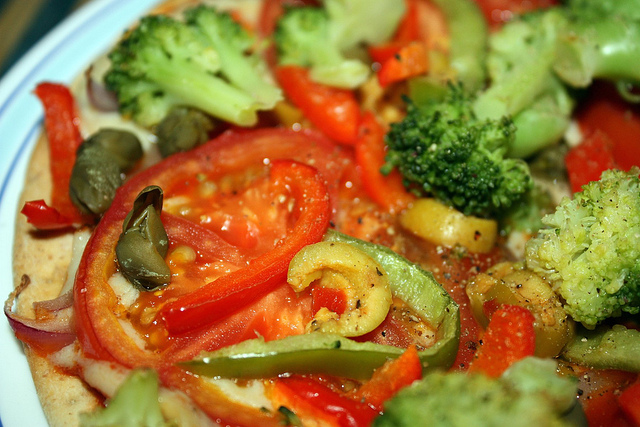Does this appear to be a healthy meal option? Indeed, the image presents what seems to be a nutritious meal choice. It is abundant in vegetables, which are excellent sources of essential vitamins, minerals, and dietary fiber. The variety of colors point towards a range of different nutrients. 